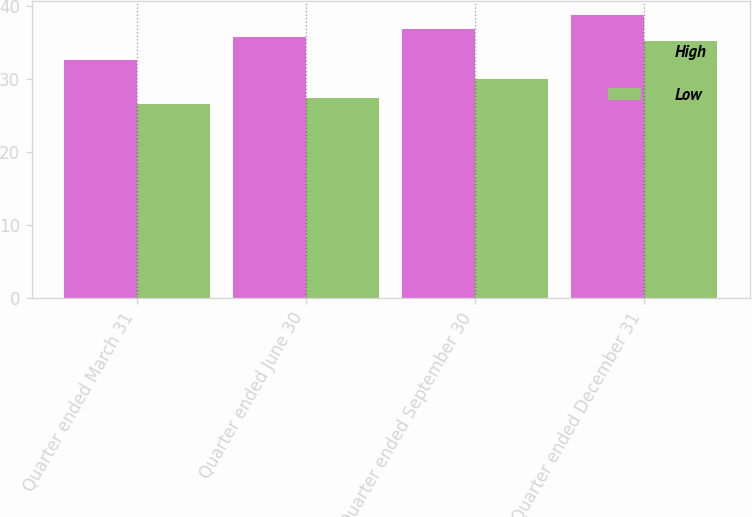<chart> <loc_0><loc_0><loc_500><loc_500><stacked_bar_chart><ecel><fcel>Quarter ended March 31<fcel>Quarter ended June 30<fcel>Quarter ended September 30<fcel>Quarter ended December 31<nl><fcel>High<fcel>32.68<fcel>35.75<fcel>36.92<fcel>38.74<nl><fcel>Low<fcel>26.66<fcel>27.35<fcel>29.98<fcel>35.21<nl></chart> 